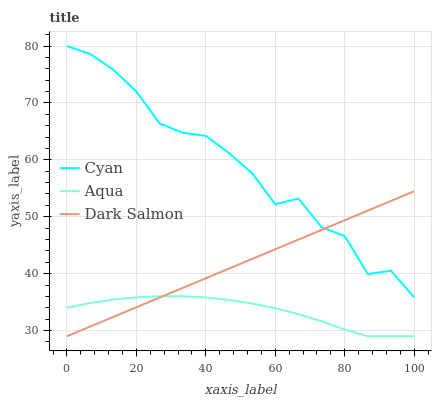Does Aqua have the minimum area under the curve?
Answer yes or no. Yes. Does Cyan have the maximum area under the curve?
Answer yes or no. Yes. Does Dark Salmon have the minimum area under the curve?
Answer yes or no. No. Does Dark Salmon have the maximum area under the curve?
Answer yes or no. No. Is Dark Salmon the smoothest?
Answer yes or no. Yes. Is Cyan the roughest?
Answer yes or no. Yes. Is Aqua the smoothest?
Answer yes or no. No. Is Aqua the roughest?
Answer yes or no. No. Does Dark Salmon have the highest value?
Answer yes or no. No. Is Aqua less than Cyan?
Answer yes or no. Yes. Is Cyan greater than Aqua?
Answer yes or no. Yes. Does Aqua intersect Cyan?
Answer yes or no. No. 